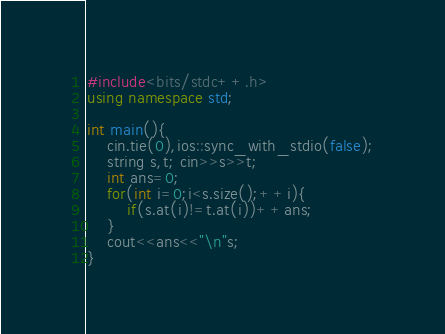<code> <loc_0><loc_0><loc_500><loc_500><_C++_>#include<bits/stdc++.h>
using namespace std;

int main(){
	cin.tie(0),ios::sync_with_stdio(false);
	string s,t; cin>>s>>t;
	int ans=0;
	for(int i=0;i<s.size();++i){
		if(s.at(i)!=t.at(i))++ans;
	}
	cout<<ans<<"\n"s;
}</code> 